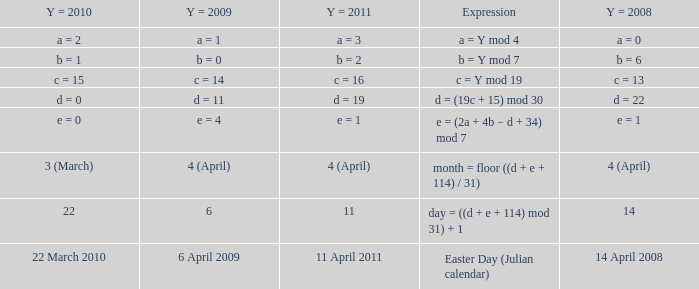What is the y = 2008 when the expression is easter day (julian calendar)? 14 April 2008. 